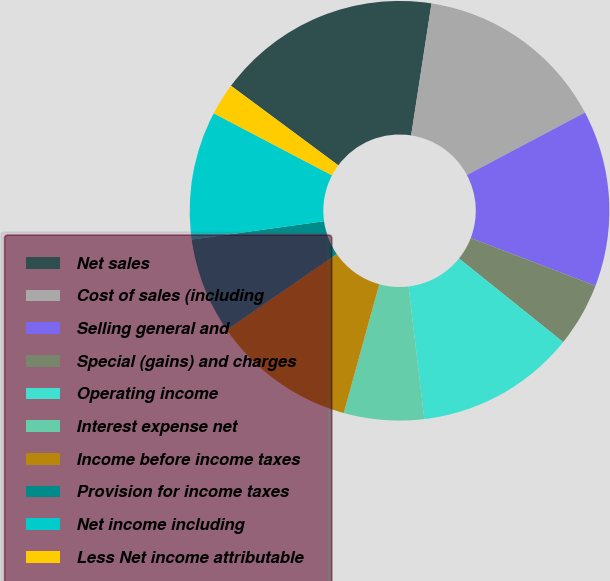<chart> <loc_0><loc_0><loc_500><loc_500><pie_chart><fcel>Net sales<fcel>Cost of sales (including<fcel>Selling general and<fcel>Special (gains) and charges<fcel>Operating income<fcel>Interest expense net<fcel>Income before income taxes<fcel>Provision for income taxes<fcel>Net income including<fcel>Less Net income attributable<nl><fcel>17.28%<fcel>14.81%<fcel>13.58%<fcel>4.94%<fcel>12.35%<fcel>6.17%<fcel>11.11%<fcel>7.41%<fcel>9.88%<fcel>2.47%<nl></chart> 